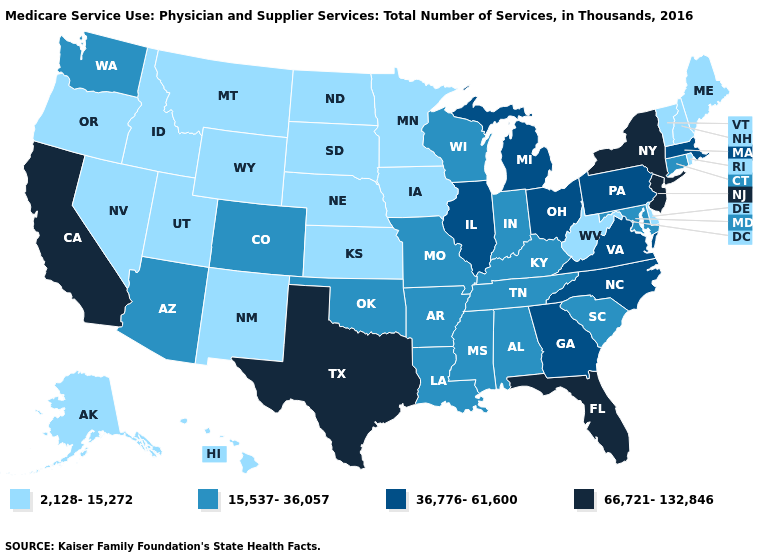What is the value of Mississippi?
Quick response, please. 15,537-36,057. Which states have the highest value in the USA?
Be succinct. California, Florida, New Jersey, New York, Texas. Name the states that have a value in the range 15,537-36,057?
Write a very short answer. Alabama, Arizona, Arkansas, Colorado, Connecticut, Indiana, Kentucky, Louisiana, Maryland, Mississippi, Missouri, Oklahoma, South Carolina, Tennessee, Washington, Wisconsin. What is the value of South Carolina?
Quick response, please. 15,537-36,057. Name the states that have a value in the range 15,537-36,057?
Quick response, please. Alabama, Arizona, Arkansas, Colorado, Connecticut, Indiana, Kentucky, Louisiana, Maryland, Mississippi, Missouri, Oklahoma, South Carolina, Tennessee, Washington, Wisconsin. Name the states that have a value in the range 36,776-61,600?
Keep it brief. Georgia, Illinois, Massachusetts, Michigan, North Carolina, Ohio, Pennsylvania, Virginia. What is the lowest value in the West?
Short answer required. 2,128-15,272. How many symbols are there in the legend?
Quick response, please. 4. Name the states that have a value in the range 2,128-15,272?
Write a very short answer. Alaska, Delaware, Hawaii, Idaho, Iowa, Kansas, Maine, Minnesota, Montana, Nebraska, Nevada, New Hampshire, New Mexico, North Dakota, Oregon, Rhode Island, South Dakota, Utah, Vermont, West Virginia, Wyoming. Does New Jersey have the highest value in the USA?
Quick response, please. Yes. Name the states that have a value in the range 15,537-36,057?
Answer briefly. Alabama, Arizona, Arkansas, Colorado, Connecticut, Indiana, Kentucky, Louisiana, Maryland, Mississippi, Missouri, Oklahoma, South Carolina, Tennessee, Washington, Wisconsin. What is the value of Utah?
Short answer required. 2,128-15,272. Does the first symbol in the legend represent the smallest category?
Be succinct. Yes. Name the states that have a value in the range 66,721-132,846?
Answer briefly. California, Florida, New Jersey, New York, Texas. Does New Hampshire have the same value as Louisiana?
Concise answer only. No. 